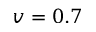Convert formula to latex. <formula><loc_0><loc_0><loc_500><loc_500>v = 0 . 7</formula> 